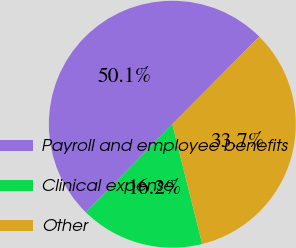<chart> <loc_0><loc_0><loc_500><loc_500><pie_chart><fcel>Payroll and employee benefits<fcel>Clinical expense<fcel>Other<nl><fcel>50.1%<fcel>16.23%<fcel>33.67%<nl></chart> 